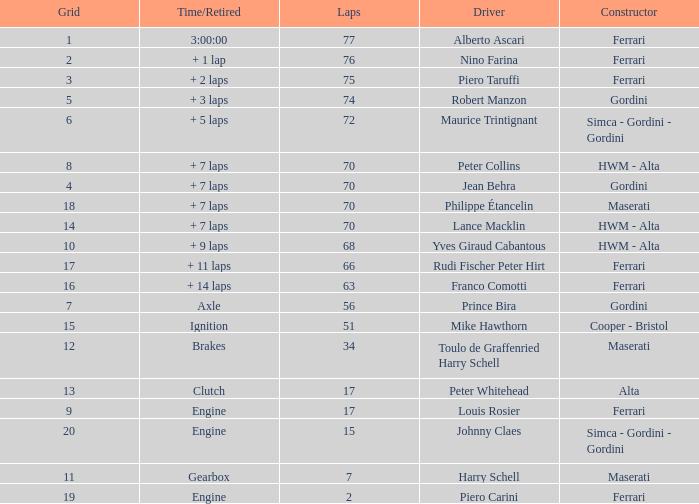What is the high grid for ferrari's with 2 laps? 19.0. 